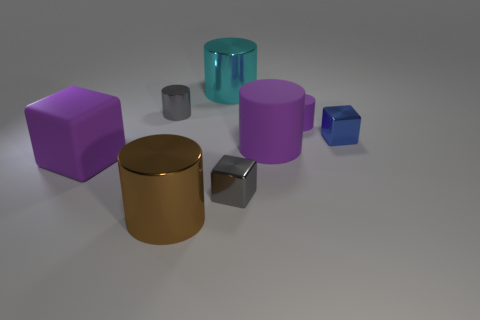Do the gray thing that is to the left of the cyan thing and the brown shiny object have the same size?
Your answer should be very brief. No. There is a tiny shiny object that is in front of the big purple block; is its color the same as the tiny metallic thing behind the small blue metal object?
Provide a succinct answer. Yes. Are any small blue matte cubes visible?
Keep it short and to the point. No. There is a big cylinder that is the same color as the tiny rubber cylinder; what is its material?
Keep it short and to the point. Rubber. There is a purple rubber object left of the tiny thing left of the tiny object that is in front of the purple block; how big is it?
Provide a succinct answer. Large. Is the shape of the large cyan thing the same as the large purple matte thing to the right of the purple matte block?
Your answer should be compact. Yes. Is there a small rubber object that has the same color as the large cube?
Offer a terse response. Yes. How many balls are small metallic objects or blue things?
Your answer should be compact. 0. Is there a large purple matte thing that has the same shape as the small purple thing?
Ensure brevity in your answer.  Yes. What number of other objects are the same color as the small matte thing?
Offer a terse response. 2. 